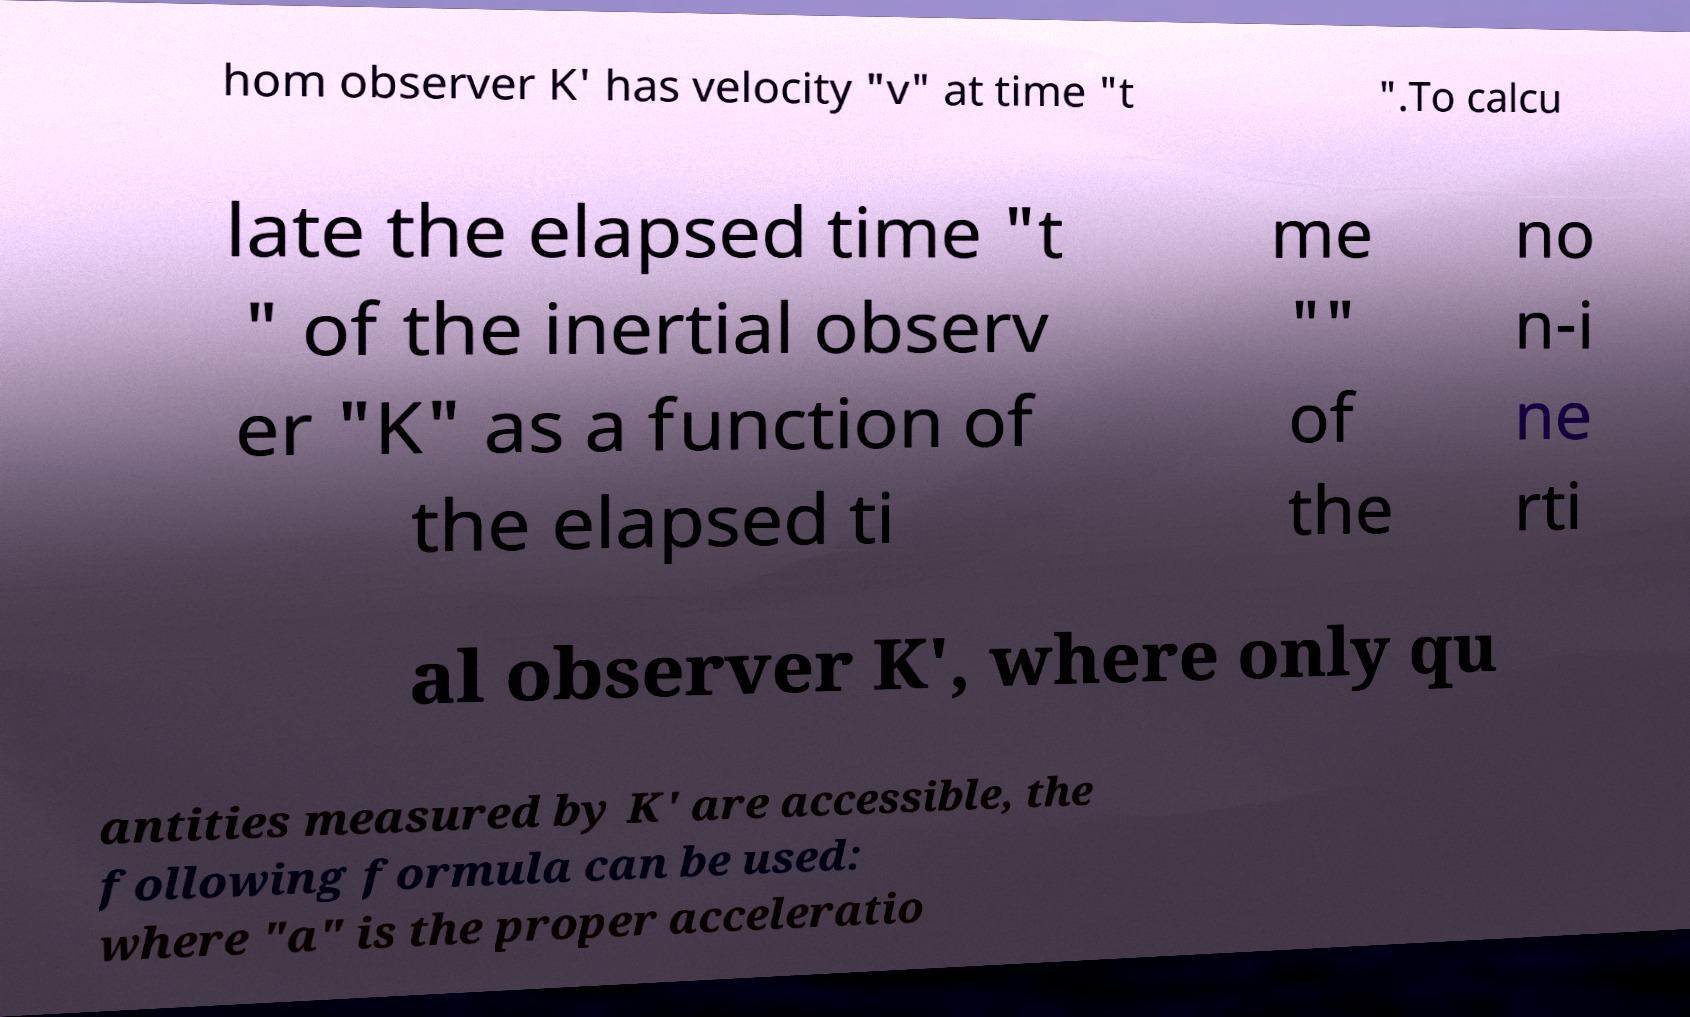Could you extract and type out the text from this image? hom observer K' has velocity "v" at time "t ".To calcu late the elapsed time "t " of the inertial observ er "K" as a function of the elapsed ti me "" of the no n-i ne rti al observer K', where only qu antities measured by K' are accessible, the following formula can be used: where "a" is the proper acceleratio 